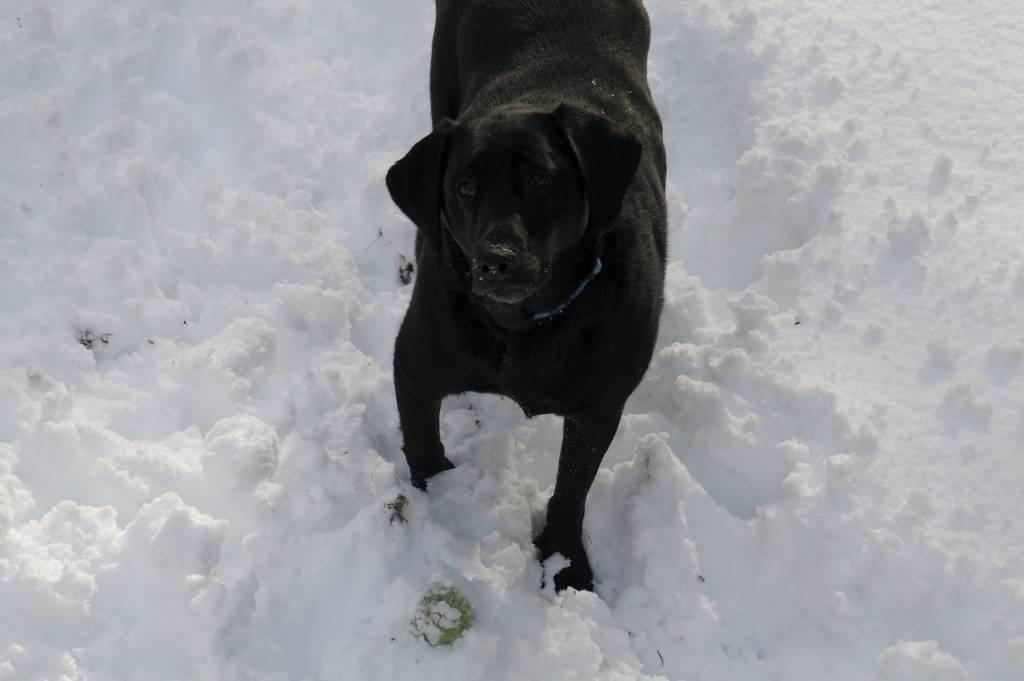What type of animal is in the image? There is a black dog in the image. What is the dog standing on? The dog is standing on the snow. How many spiders are crawling on the dog in the image? There are no spiders visible in the image; it only features a black dog standing on the snow. 